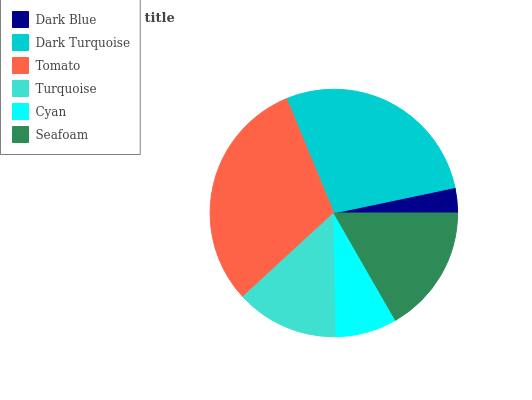Is Dark Blue the minimum?
Answer yes or no. Yes. Is Tomato the maximum?
Answer yes or no. Yes. Is Dark Turquoise the minimum?
Answer yes or no. No. Is Dark Turquoise the maximum?
Answer yes or no. No. Is Dark Turquoise greater than Dark Blue?
Answer yes or no. Yes. Is Dark Blue less than Dark Turquoise?
Answer yes or no. Yes. Is Dark Blue greater than Dark Turquoise?
Answer yes or no. No. Is Dark Turquoise less than Dark Blue?
Answer yes or no. No. Is Seafoam the high median?
Answer yes or no. Yes. Is Turquoise the low median?
Answer yes or no. Yes. Is Cyan the high median?
Answer yes or no. No. Is Seafoam the low median?
Answer yes or no. No. 